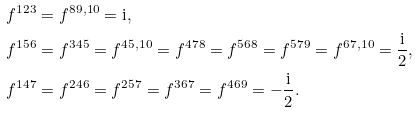Convert formula to latex. <formula><loc_0><loc_0><loc_500><loc_500>& f ^ { 1 2 3 } = f ^ { 8 9 , 1 0 } = \text {i} , \\ & f ^ { 1 5 6 } = f ^ { 3 4 5 } = f ^ { 4 5 , 1 0 } = f ^ { 4 7 8 } = f ^ { 5 6 8 } = f ^ { 5 7 9 } = f ^ { 6 7 , 1 0 } = \frac { \text {i} } { 2 } , \\ & f ^ { 1 4 7 } = f ^ { 2 4 6 } = f ^ { 2 5 7 } = f ^ { 3 6 7 } = f ^ { 4 6 9 } = - \frac { \text {i} } { 2 } .</formula> 